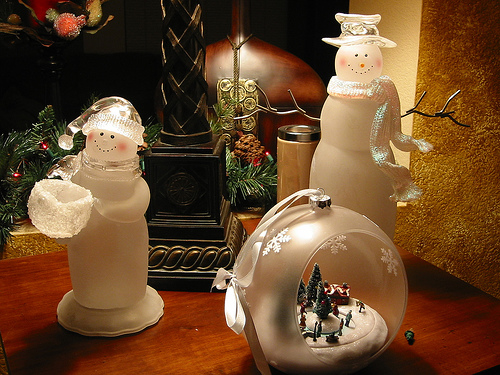<image>
Is there a ribbon on the snowman? No. The ribbon is not positioned on the snowman. They may be near each other, but the ribbon is not supported by or resting on top of the snowman. 